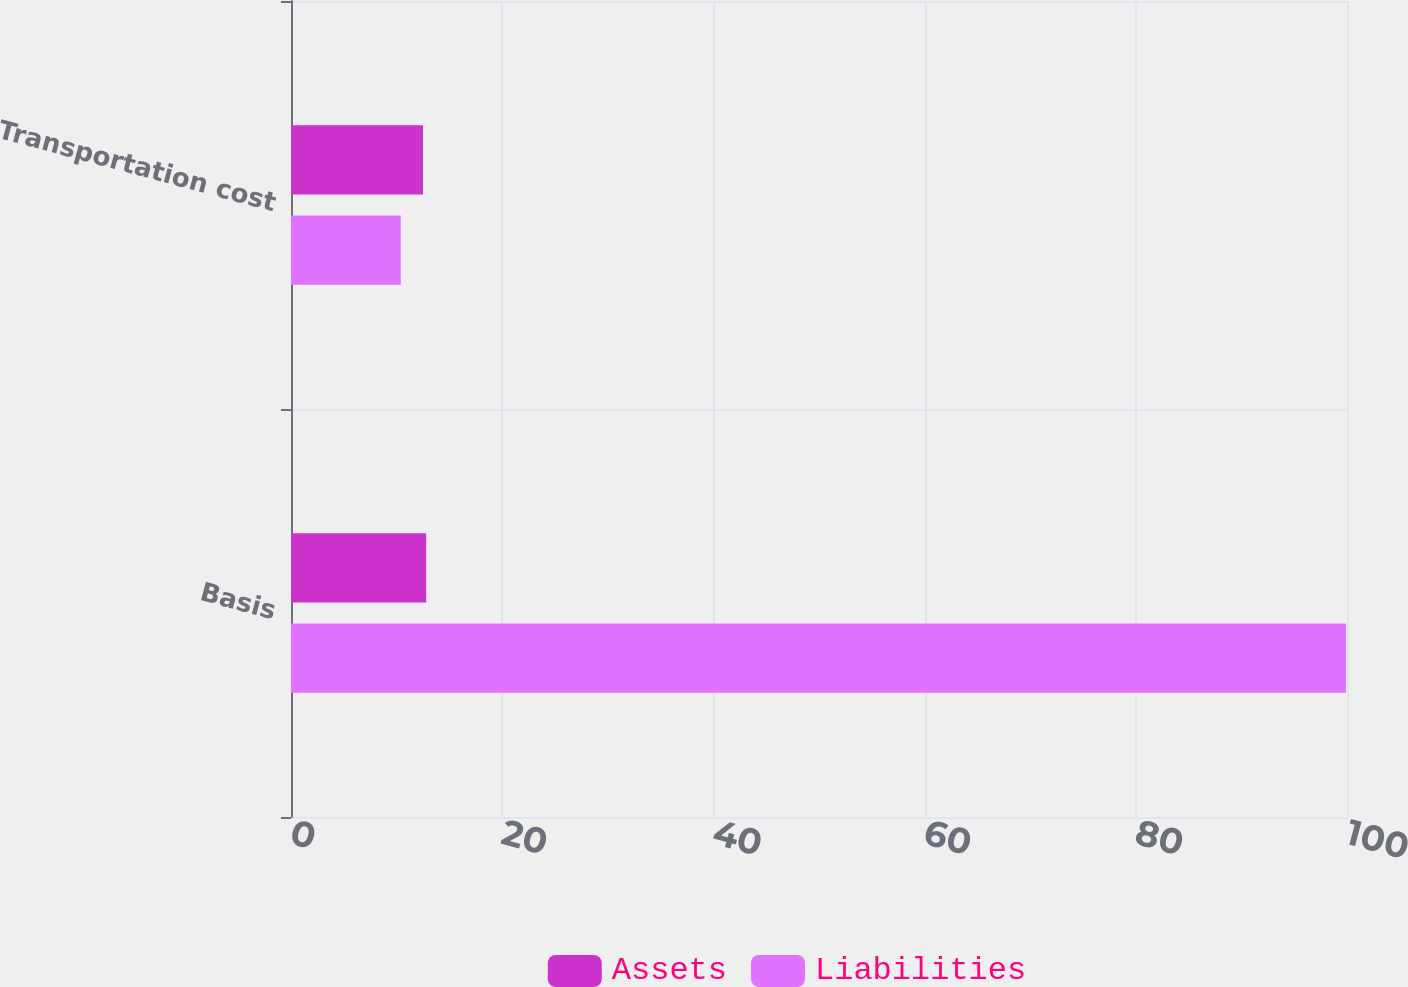Convert chart. <chart><loc_0><loc_0><loc_500><loc_500><stacked_bar_chart><ecel><fcel>Basis<fcel>Transportation cost<nl><fcel>Assets<fcel>12.8<fcel>12.5<nl><fcel>Liabilities<fcel>99.9<fcel>10.4<nl></chart> 